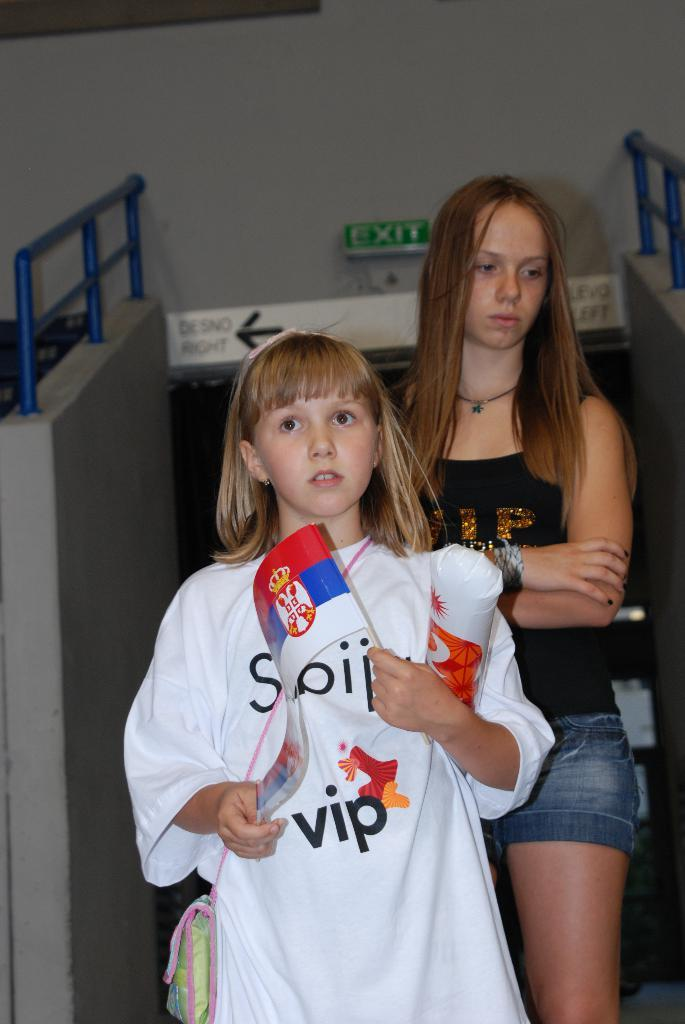Who is present in the image? There are children in the image. What are the children doing in the image? The children are standing on the floor. Can you describe any specific actions or objects held by the children? One of the children is holding a flag in their hands. What type of pot is the queen using to cook in the image? There is no queen or pot present in the image; it features children standing on the floor, with one holding a flag. 